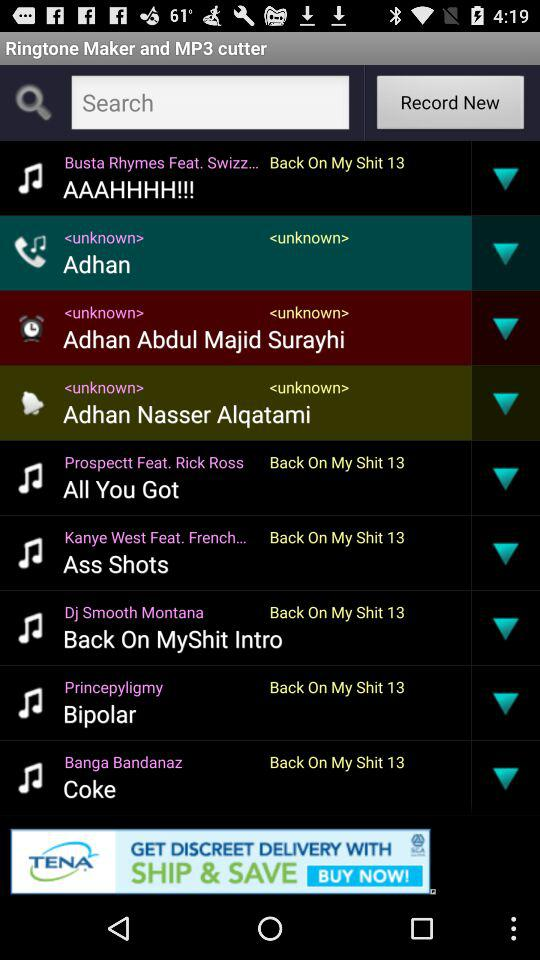Princepyligmy developed what ringtone? The ringtone is "Bipolar". 